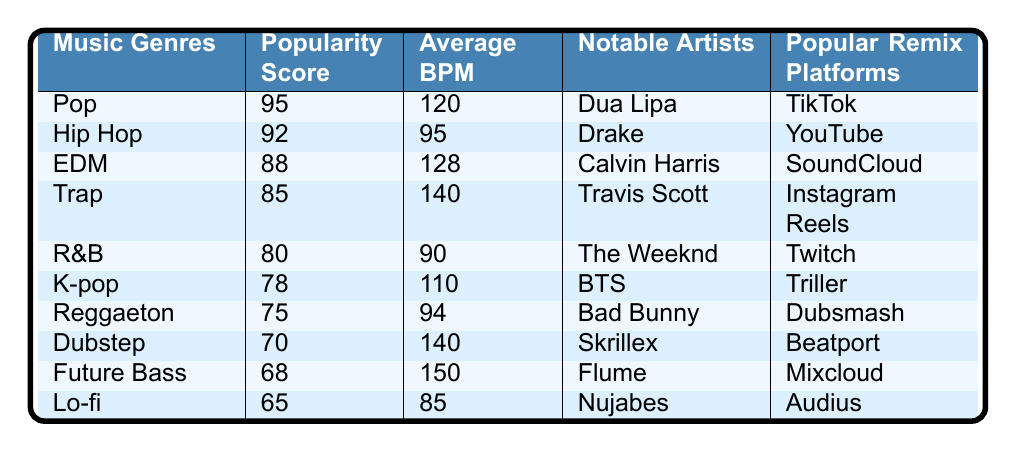What genre has the highest popularity score? The table shows the "Popularity Score" for each music genre. By looking at the scores, "Pop" has the highest score of 95.
Answer: Pop Which music genre has the lowest average BPM? According to the "Average BPM" column, "Lo-fi" has the lowest BPM with a value of 85.
Answer: Lo-fi True or false: Reggaeton is more popular than Trap. By comparing the "Popularity Score," Reggaeton has a score of 75, while Trap has a higher score of 85. Therefore, the statement is false.
Answer: False What is the average popularity score of the top three genres? The top three genres based on the popularity score are Pop (95), Hip Hop (92), and EDM (88). Their total score is 95 + 92 + 88 = 275. Dividing by 3 gives an average of 91.67.
Answer: 91.67 Which notable artist is associated with the genre that has an average BPM of 150? The genre with an average BPM of 150 is "Future Bass," and its associated notable artist is Flume.
Answer: Flume Are there more genres with a popularity score above 80 than those below 80? There are five genres above 80 (Pop, Hip Hop, EDM, Trap, R&B) and five below 80 (K-pop, Reggaeton, Dubstep, Future Bass, Lo-fi). Thus, they are equal in number.
Answer: No What is the difference between the popularity scores of K-pop and Dubstep? K-pop has a popularity score of 78, and Dubstep has a score of 70. The difference is calculated as 78 - 70 = 8.
Answer: 8 Which genre's notable artist is BTS and what is its average BPM? BTS is associated with K-pop, which has an average BPM of 110.
Answer: 110 What can you say about genres with popularity scores below 80 in terms of their average BPM? The genres with popularity scores below 80 are K-pop (average BPM 110), Reggaeton (average BPM 94), Dubstep (average BPM 140), Future Bass (average BPM 150), and Lo-fi (average BPM 85). Their average BPM is calculated as (110 + 94 + 140 + 150 + 85) / 5 = 127.8, which indicates that they have relatively high BPMs on average.
Answer: 127.8 What is the most popular remix platform for Hip Hop? Hip Hop is associated with the popular remix platform "YouTube" according to the table.
Answer: YouTube 